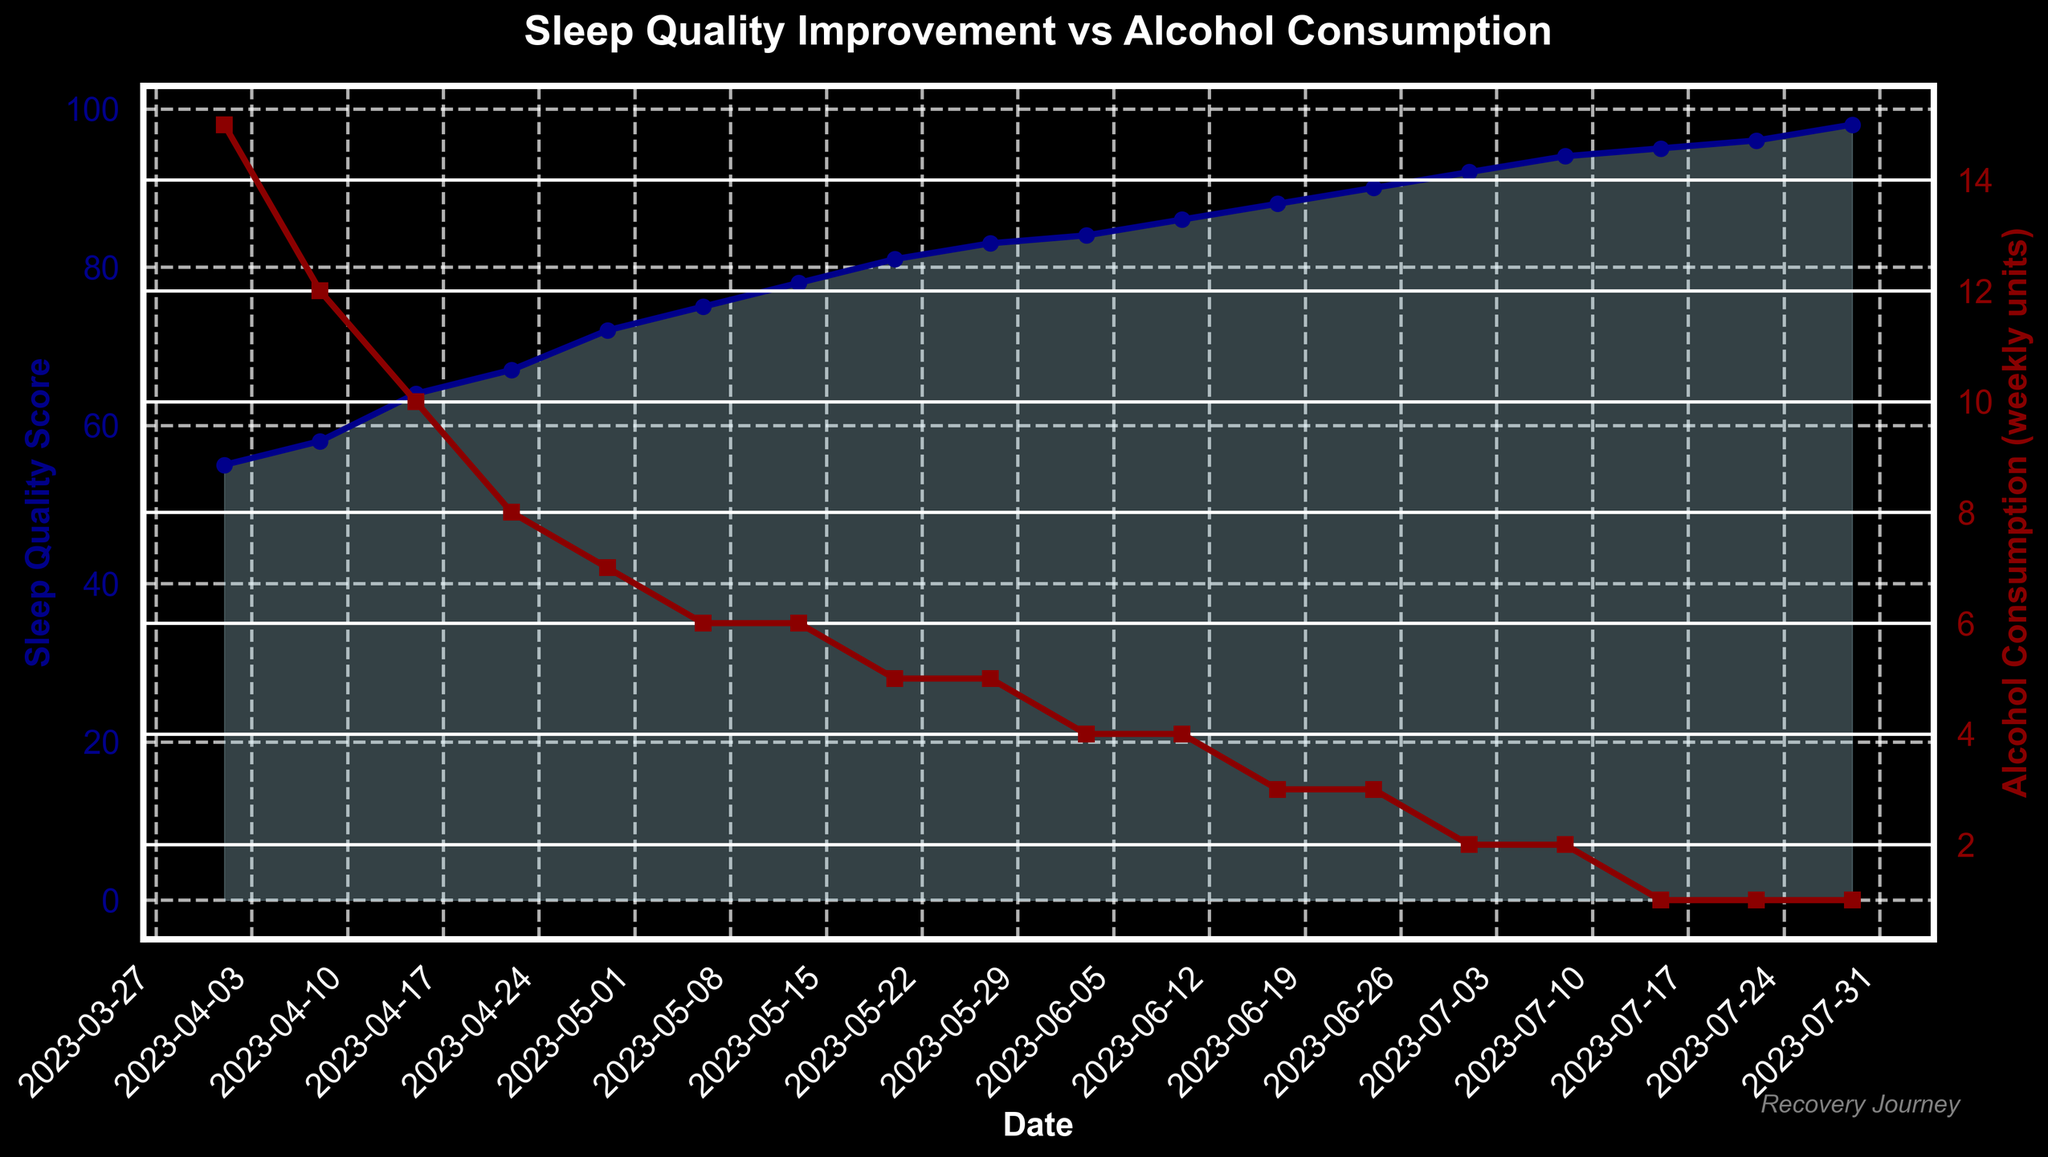What is the title of the figure? The title is located at the top of the figure and provides an overview of what the figure is about. It is clearly in bold text.
Answer: Sleep Quality Improvement vs Alcohol Consumption What color represents the Sleep Quality Score line? The Sleep Quality Score line is represented by the color provided in the legend or labels of the y-axis on the left side.
Answer: Dark blue What has happened to the alcohol consumption trend from April to July? By observing the trend line representing alcohol consumption, we can see that it has steadily decreased over time.
Answer: Decreased What is the Sleep Quality Score on the final date in the data set? By locating the final data point on the Sleep Quality Score line and checking its value, we find the score.
Answer: 98 How many data points are represented in the figure? By counting the individual markers or data points on either the Sleep Quality Score line or the Alcohol Consumption line, we determine the number of data points.
Answer: 17 What is the average Sleep Quality Score by the end of May? Identify Sleep Quality Scores for dates until May 31, sum them, and divide by the number of those points. (55+58+64+67+72+75+78+81+83+84)/10 = 717/10
Answer: 71.7 By how much did the Sleep Quality Score increase from the first to the last date? Subtract the Sleep Quality Score on April 1 from the score on July 29. (98 - 55)
Answer: 43 When did alcohol consumption first drop to 5 weekly units or less? Find the earliest date where the alcohol consumption line reaches or falls below 5 units.
Answer: 2023-05-20 Compare the therapy hours spent between April 8 and July 8. Which date had more hours and by how much? Check the therapy hours spent on April 8 and July 8 and find the difference. 7.5 hours on July 8 vs. 1.5 hours on April 8 (7.5 - 1.5).
Answer: July 8 by 6 hours Is there a correlation between decreased alcohol consumption and improved sleep quality? Observe the trends of both lines. As alcohol consumption decreases, sleep quality improves, suggesting a correlation.
Answer: Yes 